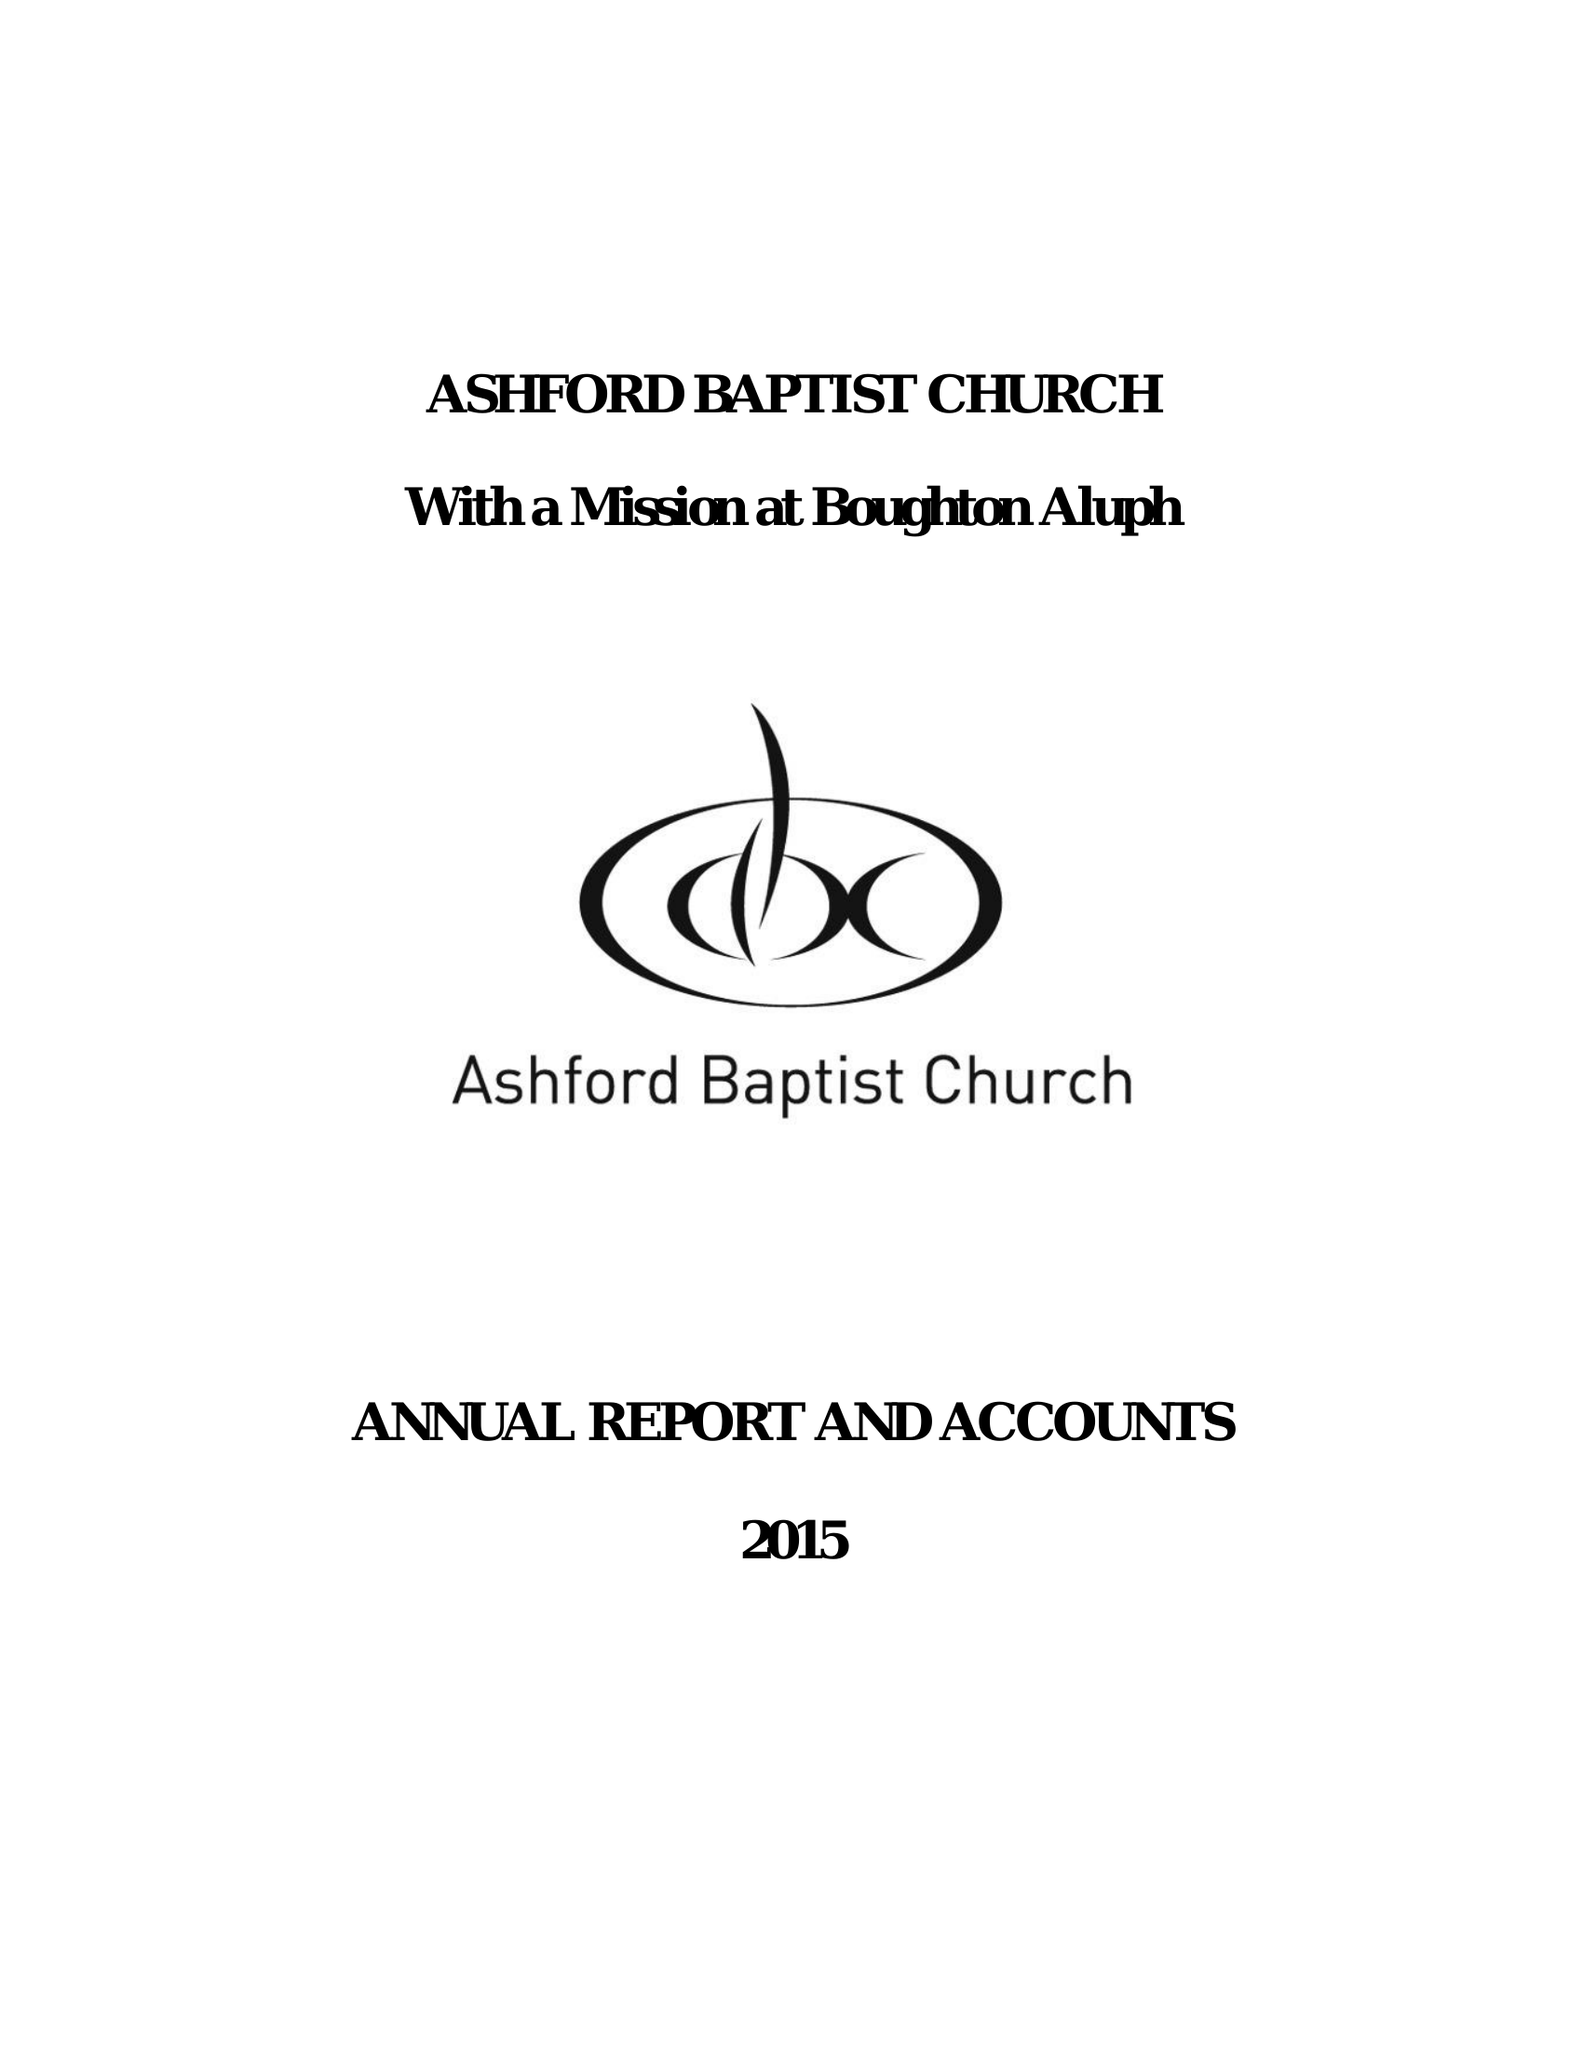What is the value for the address__postcode?
Answer the question using a single word or phrase. TN23 1PS 